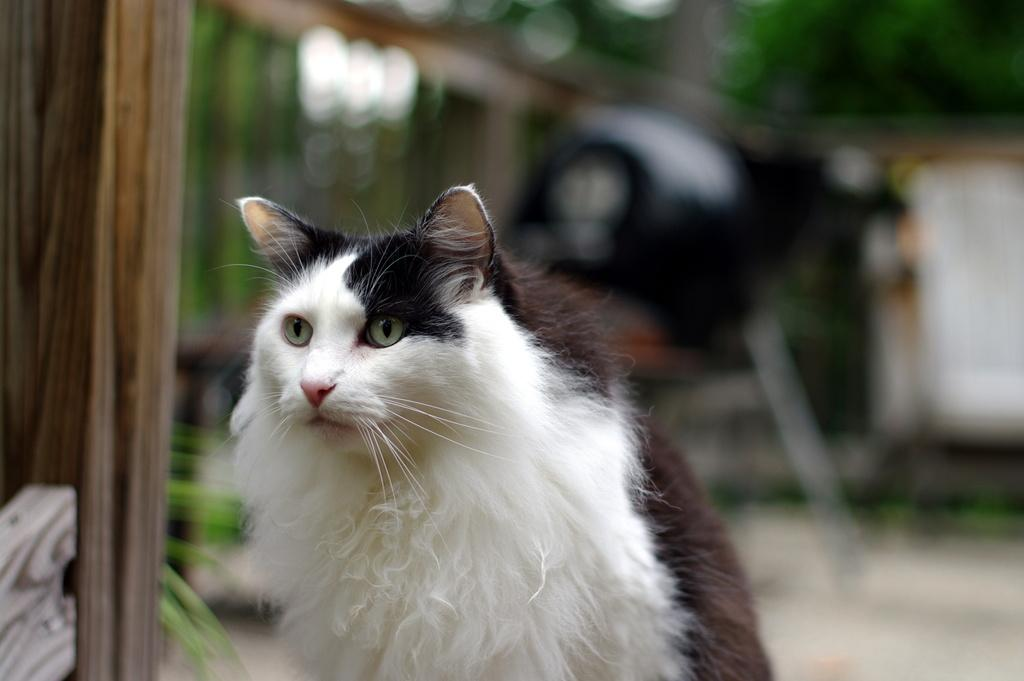What type of animal is in the image? There is a cat in the image. Can you describe the color of the cat? The cat is white and brown in color. What is located to the left of the image? There is a wooden wall to the left of the image. What can be seen in the background of the image? There are trees in the background of the image. What is visible at the bottom of the image? There is a ground visible at the bottom of the image. How does the cat provide comfort to the person in the image? There is no person present in the image, so it is not possible to determine how the cat might provide comfort. 